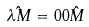Convert formula to latex. <formula><loc_0><loc_0><loc_500><loc_500>\hat { \lambda M } = 0 0 \hat { M }</formula> 